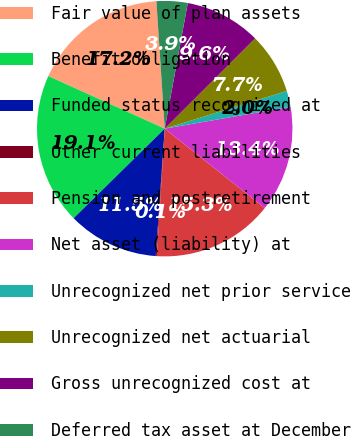Convert chart to OTSL. <chart><loc_0><loc_0><loc_500><loc_500><pie_chart><fcel>Fair value of plan assets<fcel>Benefit obligation<fcel>Funded status recognized at<fcel>Other current liabilities<fcel>Pension and postretirement<fcel>Net asset (liability) at<fcel>Unrecognized net prior service<fcel>Unrecognized net actuarial<fcel>Gross unrecognized cost at<fcel>Deferred tax asset at December<nl><fcel>17.21%<fcel>19.11%<fcel>11.52%<fcel>0.13%<fcel>15.31%<fcel>13.42%<fcel>2.03%<fcel>7.72%<fcel>9.62%<fcel>3.93%<nl></chart> 